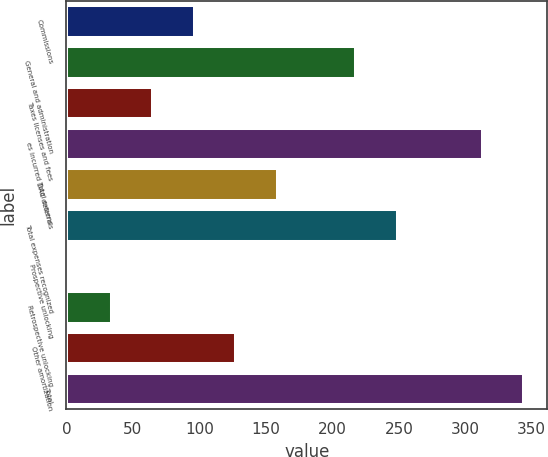Convert chart. <chart><loc_0><loc_0><loc_500><loc_500><bar_chart><fcel>Commissions<fcel>General and administration<fcel>Taxes licenses and fees<fcel>es incurred Total expens<fcel>DAC deferrals<fcel>Total expenses recognized<fcel>Prospective unlocking<fcel>Retrospective unlocking<fcel>Other amortization<fcel>Total<nl><fcel>96.6<fcel>218<fcel>65.4<fcel>313<fcel>159<fcel>249.2<fcel>3<fcel>34.2<fcel>127.8<fcel>344.2<nl></chart> 